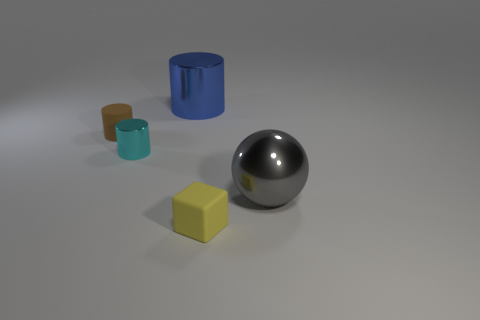In a physical setting, what kind of environment would produce such soft shadows as seen around the objects? Soft shadows like those around the objects in the image are typically produced in an environment with diffused lighting. This can occur outdoors on an overcast day or indoors with light sources that are scattered or softened through the use of diffusers, like white fabric or frosted glass, which spread the light across a wider area and minimize harsh shadows. 